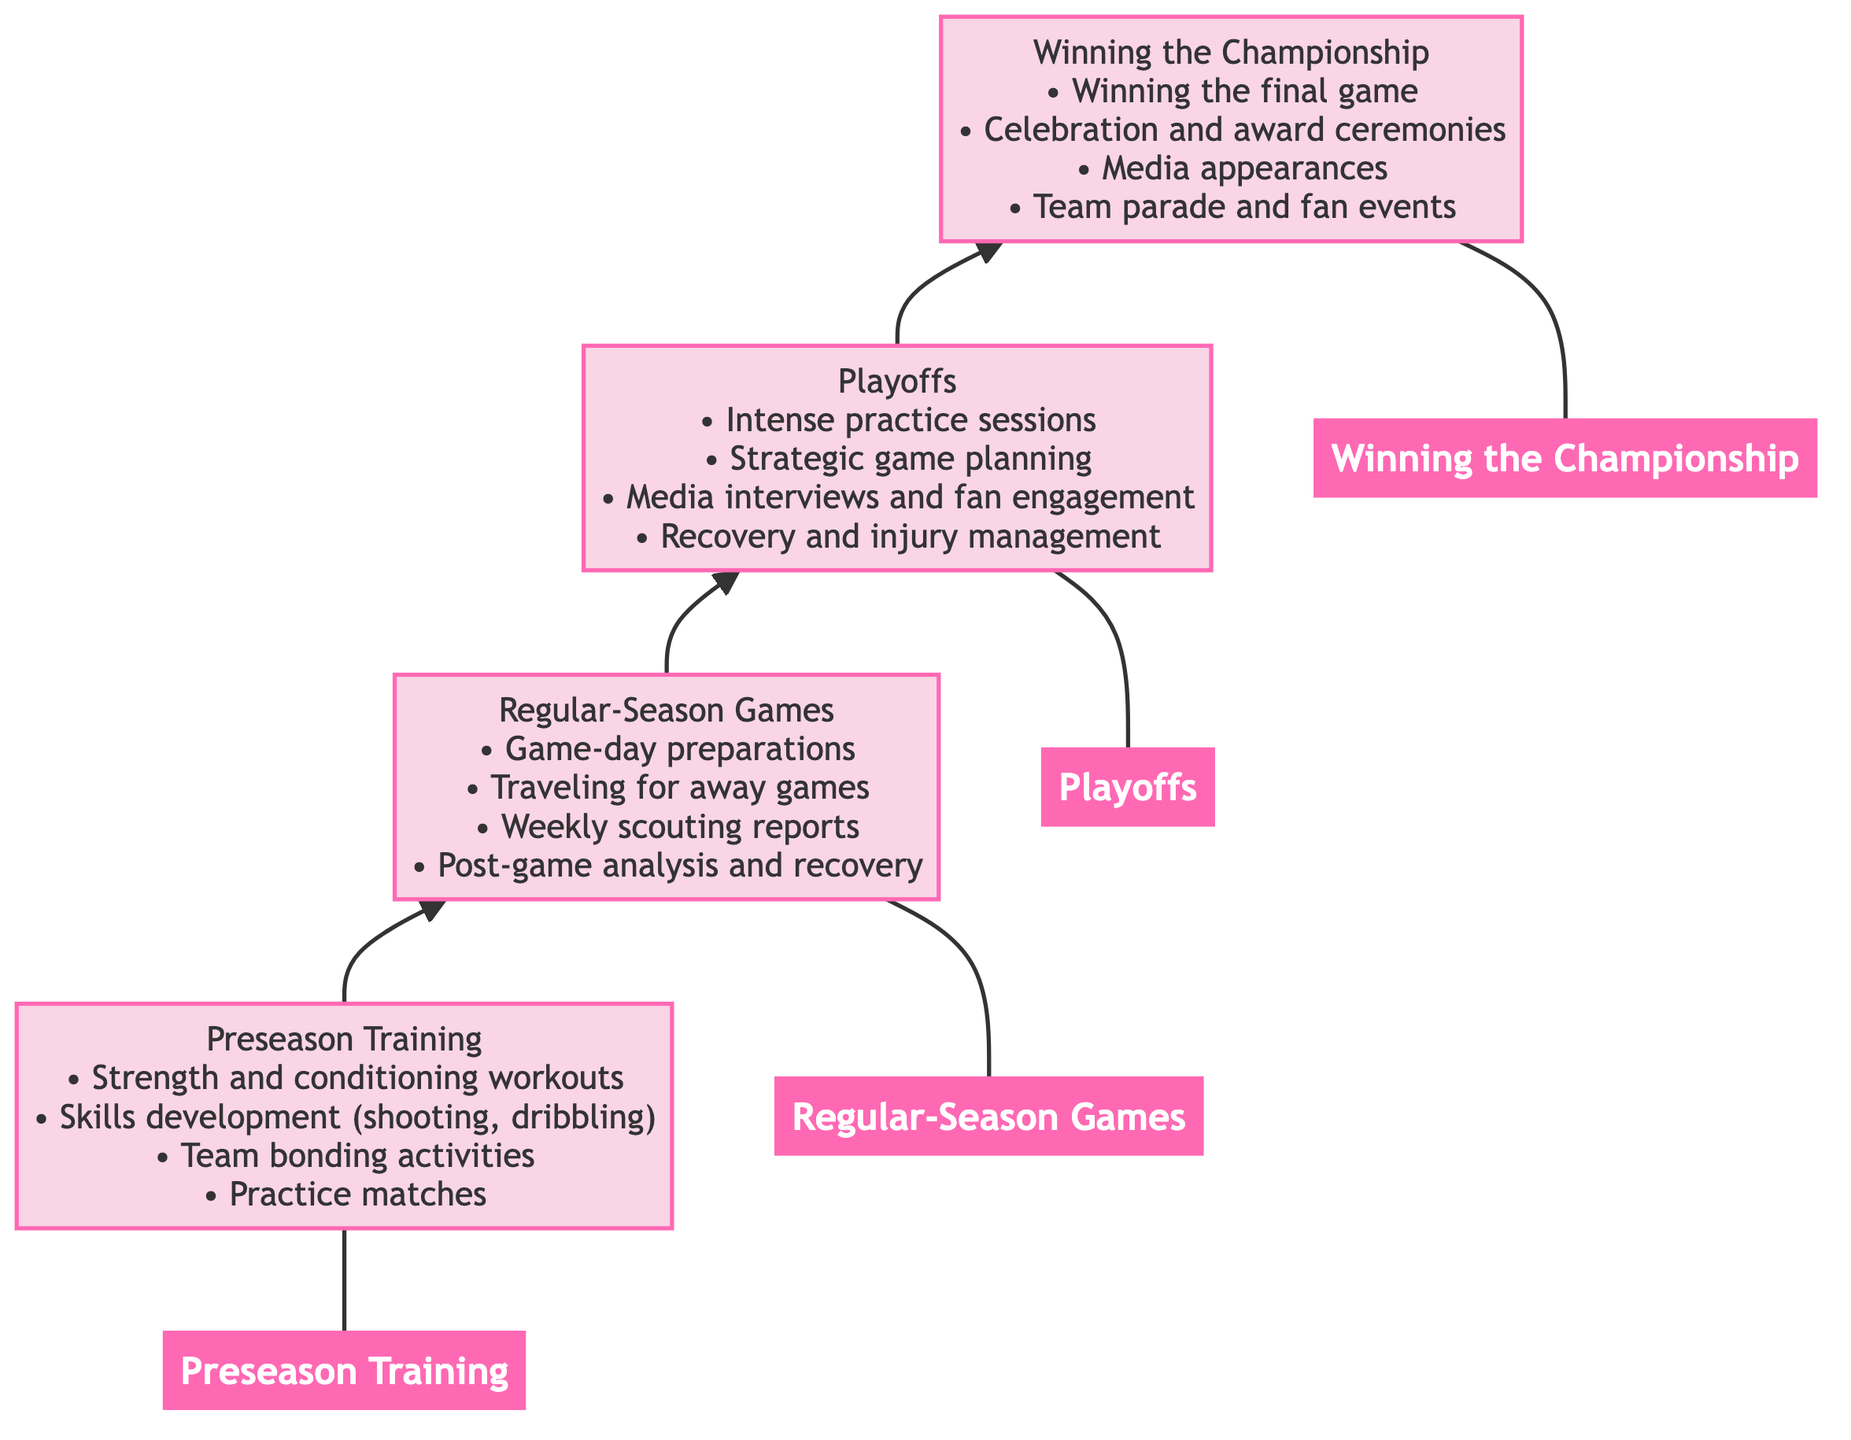What is the first stage in the flow chart? The flow chart starts with "Preseason Training," which is the first node at the bottom of the diagram.
Answer: Preseason Training How many key activities are listed for Regular-Season Games? The "Regular-Season Games" node includes four key activities listed under it.
Answer: 4 What follows Playoffs in the progression? The progression moves from "Playoffs" to "Winning the Championship," indicating that Winning the Championship follows Playoffs.
Answer: Winning the Championship Which level includes media appearances? "Winning the Championship" is the level that includes activities such as media appearances as part of the celebration.
Answer: Winning the Championship What type of activities are associated with Preseason Training? The activities mentioned for "Preseason Training" are primarily focused on physical conditioning, skills, and team bonding.
Answer: Intensive physical conditioning, skills drills, and team strategy sessions How many stages are in the full progression of the women's basketball season? The flow chart outlines four distinct stages in the women's basketball season's progression.
Answer: 4 What is a key focus during Playoffs? A key focus during "Playoffs" is "Strategic game planning," which is crucial for success in high-stakes matches.
Answer: Strategic game planning What celebration occurs after winning the final game? After winning the final game, there are celebration and award ceremonies included as key activities upon winning the championship.
Answer: Celebration and award ceremonies In which stage do team bonding activities occur? Team bonding activities are primarily featured during the "Preseason Training" stage of the flow chart.
Answer: Preseason Training 